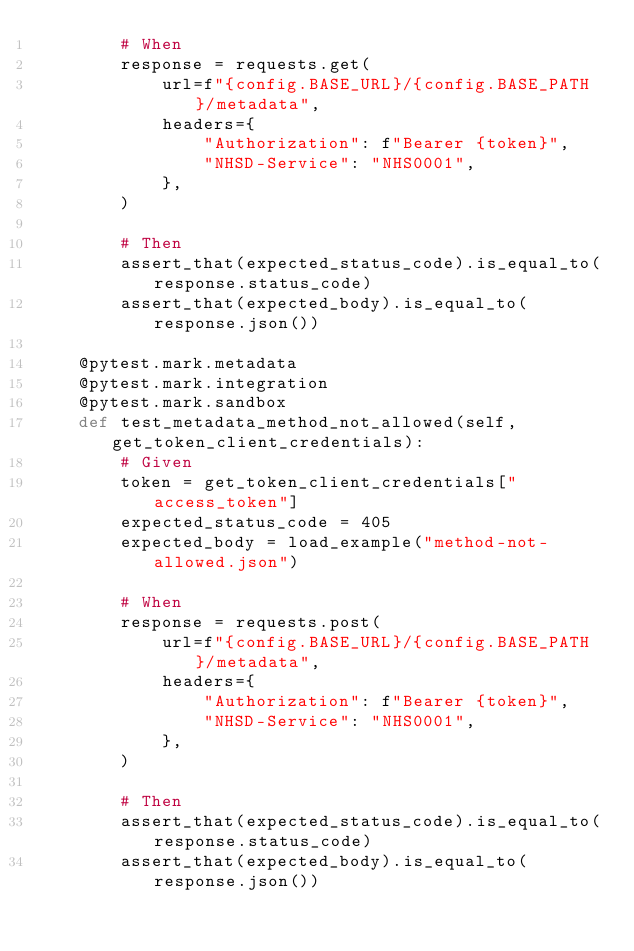<code> <loc_0><loc_0><loc_500><loc_500><_Python_>        # When
        response = requests.get(
            url=f"{config.BASE_URL}/{config.BASE_PATH}/metadata",
            headers={
                "Authorization": f"Bearer {token}",
                "NHSD-Service": "NHS0001",
            },
        )

        # Then
        assert_that(expected_status_code).is_equal_to(response.status_code)
        assert_that(expected_body).is_equal_to(response.json())

    @pytest.mark.metadata
    @pytest.mark.integration
    @pytest.mark.sandbox
    def test_metadata_method_not_allowed(self, get_token_client_credentials):
        # Given
        token = get_token_client_credentials["access_token"]
        expected_status_code = 405
        expected_body = load_example("method-not-allowed.json")

        # When
        response = requests.post(
            url=f"{config.BASE_URL}/{config.BASE_PATH}/metadata",
            headers={
                "Authorization": f"Bearer {token}",
                "NHSD-Service": "NHS0001",
            },
        )

        # Then
        assert_that(expected_status_code).is_equal_to(response.status_code)
        assert_that(expected_body).is_equal_to(response.json())
</code> 